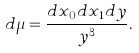<formula> <loc_0><loc_0><loc_500><loc_500>d \mu = \frac { d x _ { 0 } d x _ { 1 } d y } { y ^ { 3 } } .</formula> 